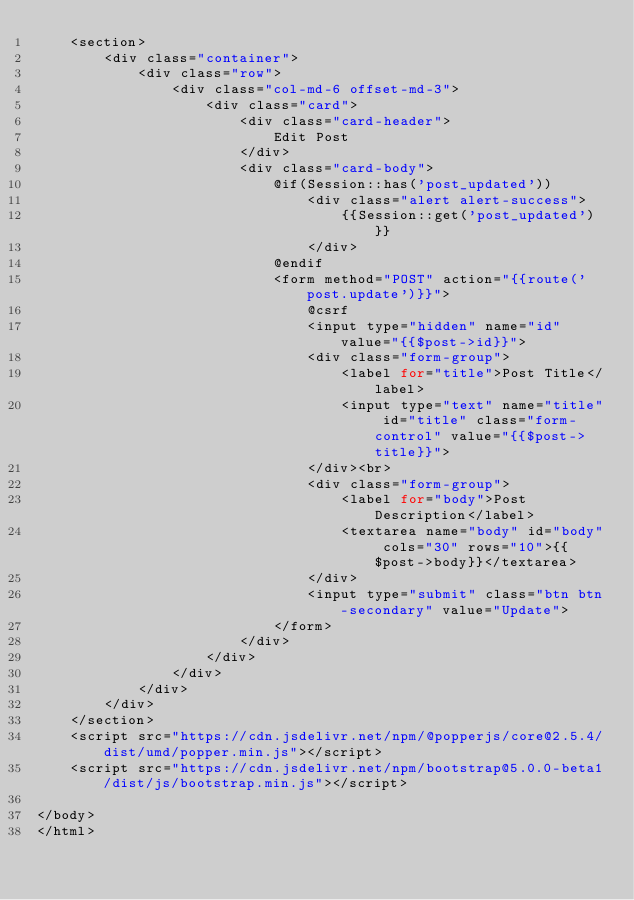Convert code to text. <code><loc_0><loc_0><loc_500><loc_500><_PHP_>    <section>
        <div class="container">
            <div class="row">
                <div class="col-md-6 offset-md-3">
                    <div class="card">
                        <div class="card-header">
                            Edit Post
                        </div>
                        <div class="card-body">
                            @if(Session::has('post_updated'))
                                <div class="alert alert-success">
                                    {{Session::get('post_updated')}}
                                </div>
                            @endif
                            <form method="POST" action="{{route('post.update')}}">
                                @csrf
                                <input type="hidden" name="id" value="{{$post->id}}">
                                <div class="form-group">
                                    <label for="title">Post Title</label>
                                    <input type="text" name="title" id="title" class="form-control" value="{{$post->title}}">
                                </div><br>
                                <div class="form-group">
                                    <label for="body">Post Description</label>
                                    <textarea name="body" id="body" cols="30" rows="10">{{$post->body}}</textarea>
                                </div>
                                <input type="submit" class="btn btn-secondary" value="Update">
                            </form>
                        </div>
                    </div>
                </div>
            </div>
        </div>
    </section>
    <script src="https://cdn.jsdelivr.net/npm/@popperjs/core@2.5.4/dist/umd/popper.min.js"></script>
    <script src="https://cdn.jsdelivr.net/npm/bootstrap@5.0.0-beta1/dist/js/bootstrap.min.js"></script>

</body>
</html></code> 